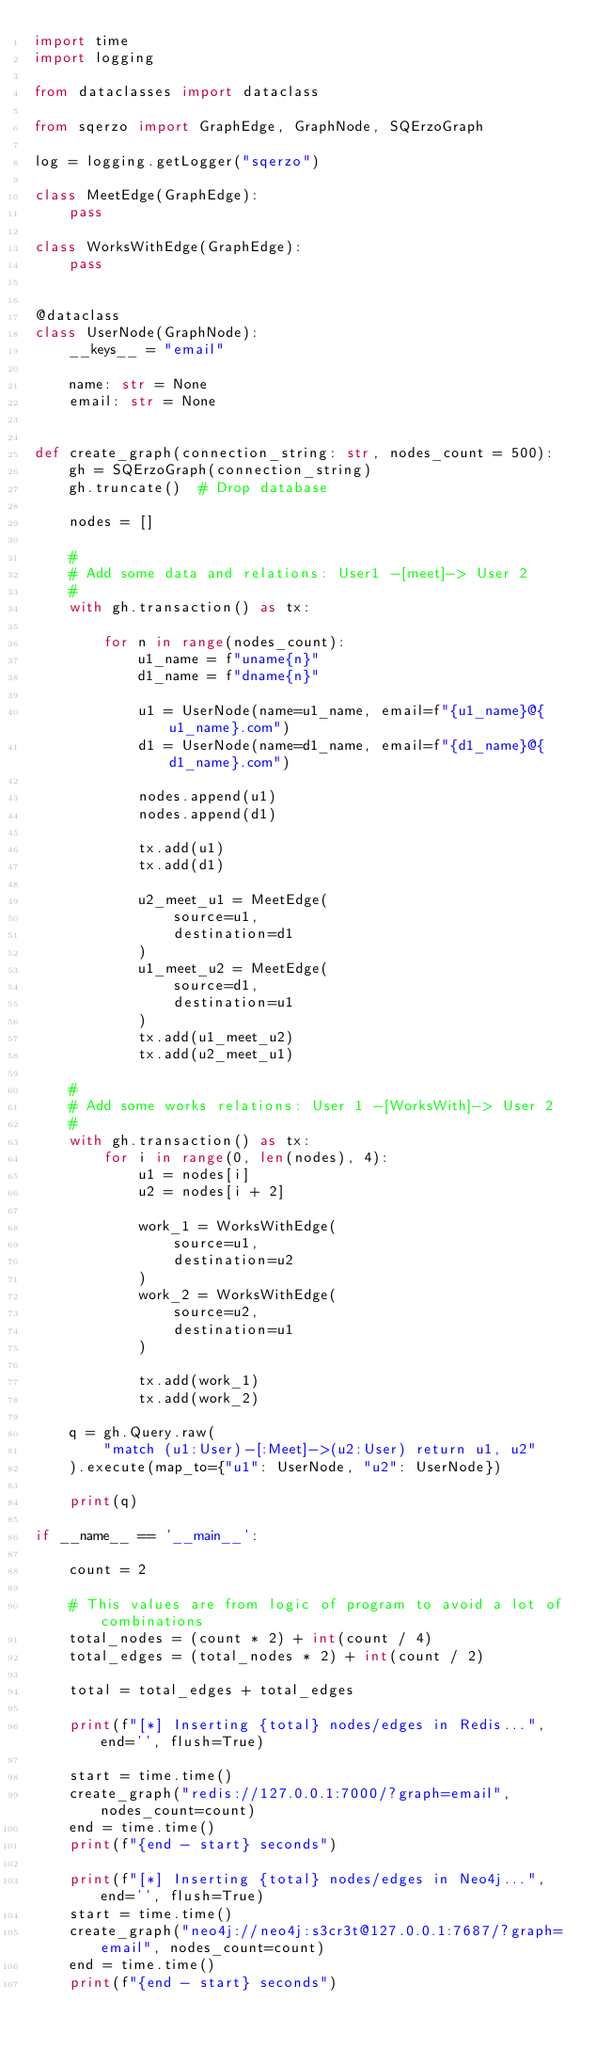<code> <loc_0><loc_0><loc_500><loc_500><_Python_>import time
import logging

from dataclasses import dataclass

from sqerzo import GraphEdge, GraphNode, SQErzoGraph

log = logging.getLogger("sqerzo")

class MeetEdge(GraphEdge):
    pass

class WorksWithEdge(GraphEdge):
    pass


@dataclass
class UserNode(GraphNode):
    __keys__ = "email"

    name: str = None
    email: str = None


def create_graph(connection_string: str, nodes_count = 500):
    gh = SQErzoGraph(connection_string)
    gh.truncate()  # Drop database

    nodes = []

    #
    # Add some data and relations: User1 -[meet]-> User 2
    #
    with gh.transaction() as tx:

        for n in range(nodes_count):
            u1_name = f"uname{n}"
            d1_name = f"dname{n}"

            u1 = UserNode(name=u1_name, email=f"{u1_name}@{u1_name}.com")
            d1 = UserNode(name=d1_name, email=f"{d1_name}@{d1_name}.com")

            nodes.append(u1)
            nodes.append(d1)

            tx.add(u1)
            tx.add(d1)

            u2_meet_u1 = MeetEdge(
                source=u1,
                destination=d1
            )
            u1_meet_u2 = MeetEdge(
                source=d1,
                destination=u1
            )
            tx.add(u1_meet_u2)
            tx.add(u2_meet_u1)

    #
    # Add some works relations: User 1 -[WorksWith]-> User 2
    #
    with gh.transaction() as tx:
        for i in range(0, len(nodes), 4):
            u1 = nodes[i]
            u2 = nodes[i + 2]

            work_1 = WorksWithEdge(
                source=u1,
                destination=u2
            )
            work_2 = WorksWithEdge(
                source=u2,
                destination=u1
            )

            tx.add(work_1)
            tx.add(work_2)

    q = gh.Query.raw(
        "match (u1:User)-[:Meet]->(u2:User) return u1, u2"
    ).execute(map_to={"u1": UserNode, "u2": UserNode})

    print(q)

if __name__ == '__main__':

    count = 2

    # This values are from logic of program to avoid a lot of combinations
    total_nodes = (count * 2) + int(count / 4)
    total_edges = (total_nodes * 2) + int(count / 2)

    total = total_edges + total_edges

    print(f"[*] Inserting {total} nodes/edges in Redis...", end='', flush=True)

    start = time.time()
    create_graph("redis://127.0.0.1:7000/?graph=email", nodes_count=count)
    end = time.time()
    print(f"{end - start} seconds")

    print(f"[*] Inserting {total} nodes/edges in Neo4j...", end='', flush=True)
    start = time.time()
    create_graph("neo4j://neo4j:s3cr3t@127.0.0.1:7687/?graph=email", nodes_count=count)
    end = time.time()
    print(f"{end - start} seconds")
</code> 